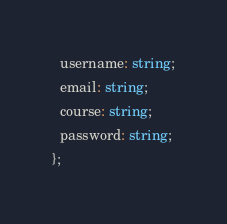Convert code to text. <code><loc_0><loc_0><loc_500><loc_500><_TypeScript_>  username: string;
  email: string;
  course: string;
  password: string;
};
</code> 